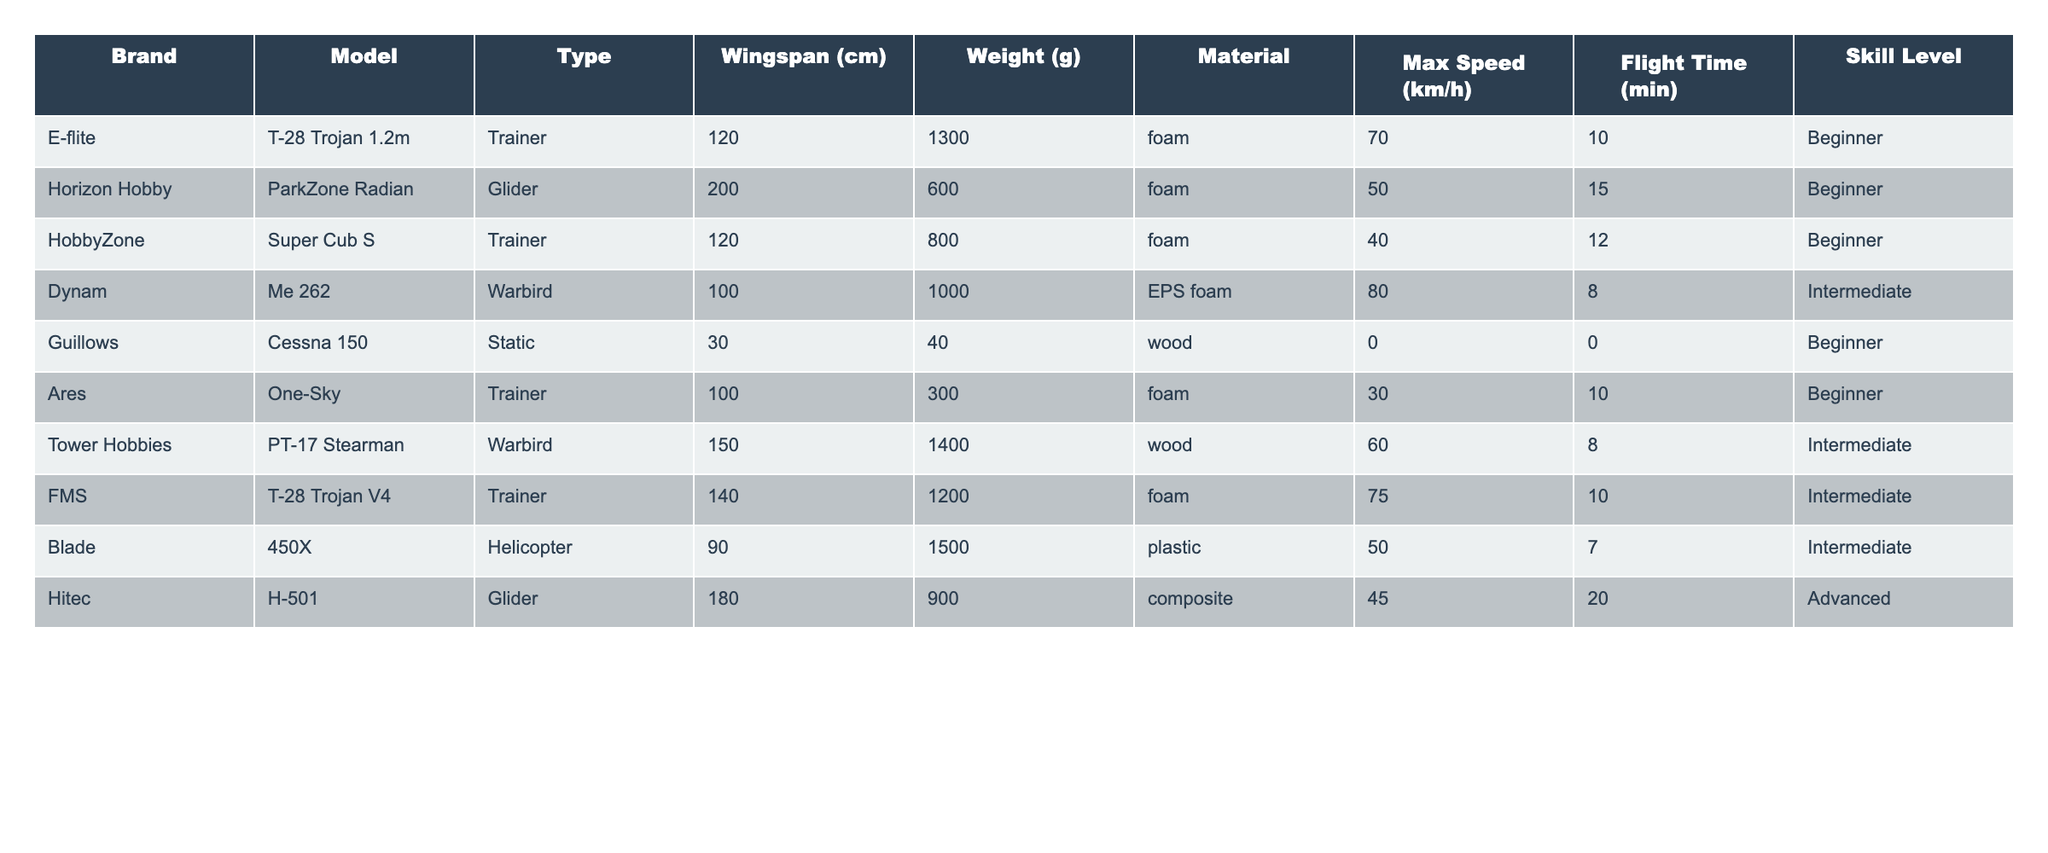What is the wingspan of the ParkZone Radian? The wingspan for the ParkZone Radian is explicitly listed in the table under the Wingspan (cm) column, which states it is 200 cm.
Answer: 200 cm Which model has the highest max speed? By checking the Max Speed (km/h) column, I can see that the model with the highest speed is the E-flite T-28 Trojan 1.2m with a max speed of 70 km/h.
Answer: 70 km/h What is the weight of the Cessna 150? The weight of the Cessna 150 is shown in the Weight (g) column of the table, which indicates it weighs 40 grams.
Answer: 40 grams How many models are classified as Trainers? Counting the number of times "Trainer" appears in the Type column shows that there are 5 models classified as Trainers.
Answer: 5 What is the average flight time of all models? First, I sum the flight times of all the models: (10 + 15 + 12 + 8 + 0 + 10 + 8 + 10 + 7 + 20) = 100 minutes. Then, I divide by the number of models (10) to get the average: 100/10 = 10 minutes.
Answer: 10 minutes Which model is the lightest? Looking at the Weight (g) column, the Cessna 150 has the lowest weight at 40 grams.
Answer: Cessna 150 Is the Blade 450X an Advanced level model? The table lists the skill level for Blade 450X as Intermediate, which means it is not classified as Advanced.
Answer: No What type of material is used for the FMS T-28 Trojan V4? The material for the FMS T-28 Trojan V4 is specified in the Material column, which indicates it is made of foam.
Answer: Foam What is the difference in wingspan between the T-28 Trojan 1.2m and the PT-17 Stearman? The wingspan of the T-28 Trojan 1.2m is 120 cm and the PT-17 Stearman is 150 cm. The difference is 150 - 120 = 30 cm.
Answer: 30 cm If I want a model with a flight time of at least 12 minutes, which models should I consider? Checking the Flight Time (min) column, I find that the models with flight times of at least 12 minutes are ParkZone Radian (15), Super Cub S (12), H-501 (20).
Answer: ParkZone Radian, Super Cub S, H-501 